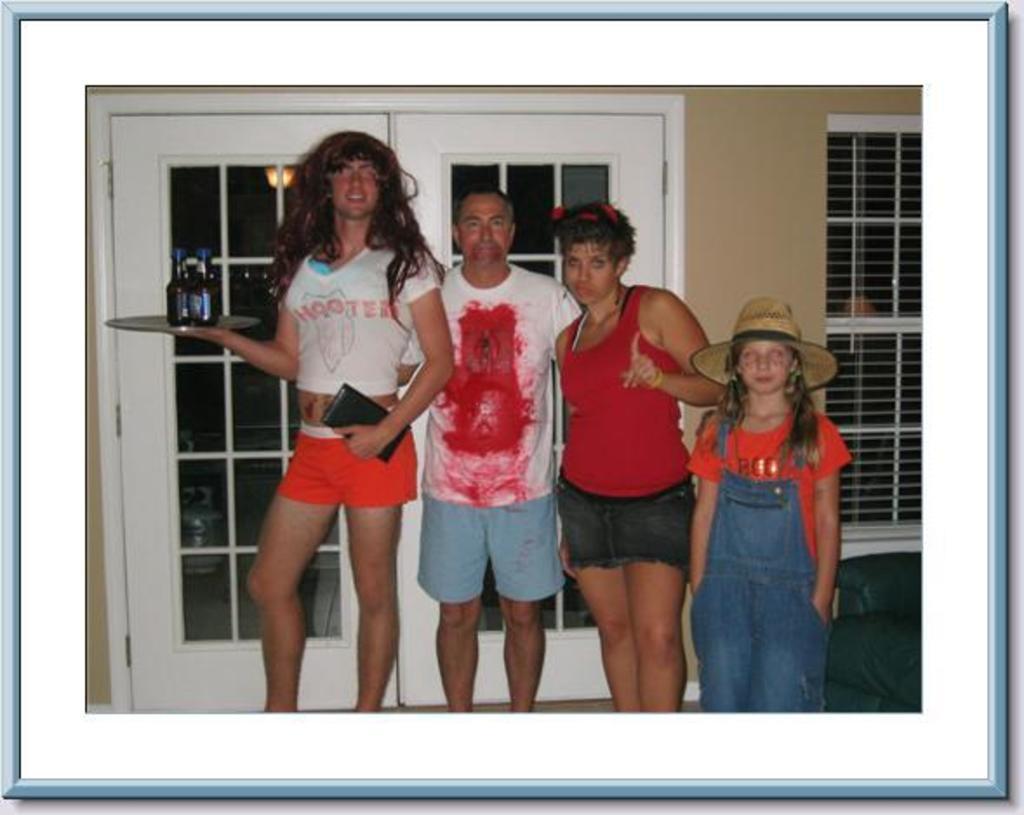What restaurant does the shirt on the person on the left represent?
Provide a short and direct response. Hooters. 